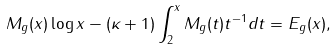Convert formula to latex. <formula><loc_0><loc_0><loc_500><loc_500>M _ { g } ( x ) \log x - ( \kappa + 1 ) \int _ { 2 } ^ { x } M _ { g } ( t ) t ^ { - 1 } d t = E _ { g } ( x ) ,</formula> 